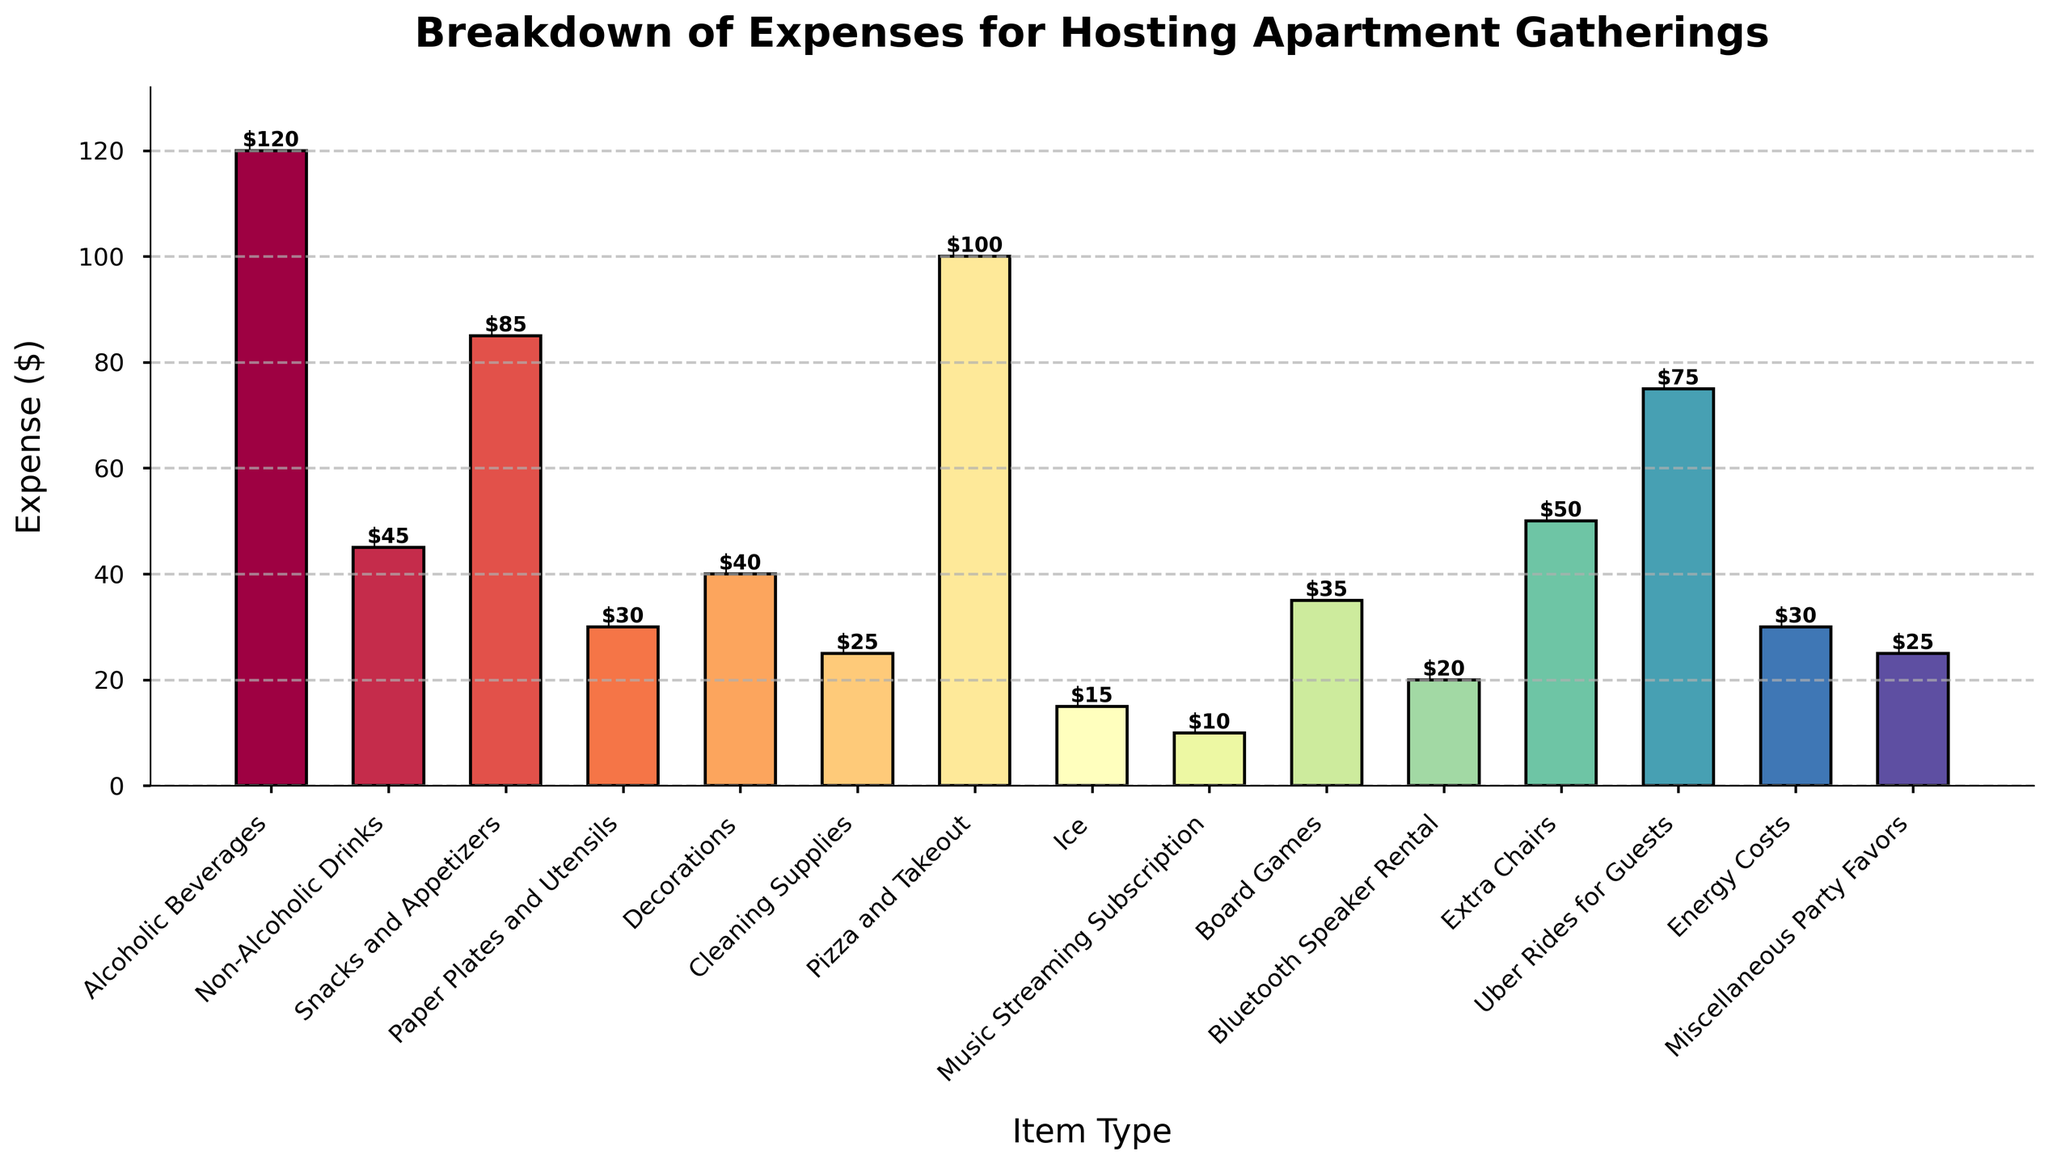Which item type has the highest expense? By looking at the height of the bars, we can see that the bar for "Alcoholic Beverages" is the tallest, indicating it has the highest expense.
Answer: Alcoholic Beverages Which item type has the lowest expense? By observing the heights of the bars, we can see that the "Music Streaming Subscription" bar is the shortest, indicating it has the lowest expense.
Answer: Music Streaming Subscription What is the total expense for both Snacks and Appetizers and Pizza and Takeout? The expense for "Snacks and Appetizers" is $85 and for "Pizza and Takeout" is $100. Adding them together, we get 85 + 100 = 185.
Answer: $185 Are the expenses for Décor and Paper Plates and Utensils equal? The expense for "Decorations" is $40 and for "Paper Plates and Utensils" is $30. Since 40 is not equal to 30, the expenses are not equal.
Answer: No What is the combined expense of the three highest-cost items? The three highest-cost items are "Alcoholic Beverages" ($120), "Pizza and Takeout" ($100), and "Uber Rides for Guests" ($75). The combined expense is 120 + 100 + 75 = 295.
Answer: $295 How does the expense for Extra Chairs compare to Decorations? The expense for "Extra Chairs" is $50, while for "Decorations" it is $40. Since 50 is greater than 40, the expense for Extra Chairs is higher.
Answer: Extra Chairs > Decorations Which category costs more: Cleaning Supplies or Miscellaneous Party Favors? The expense for "Cleaning Supplies" is $25 and for "Miscellaneous Party Favors" is $25. Since both are equal, neither category costs more.
Answer: Equal How much more do Snacks and Appetizers cost compared to Non-Alcoholic Drinks? The expense for "Snacks and Appetizers" is $85 and for "Non-Alcoholic Drinks" is $45. The difference is 85 - 45 = 40.
Answer: $40 Is the expense for Ice less than Energy Costs? The expense for "Ice" is $15 and for "Energy Costs" is $30. Since 15 is less than 30, the expense for Ice is indeed less.
Answer: Yes What is the median expense of all the listed items? To find the median, we first list all the expenses in ascending order: 10, 15, 20, 25, 25, 30, 30, 35, 40, 45, 50, 75, 85, 100, 120. With 15 items, the median is the 8th value. The 8th value is 35.
Answer: $35 